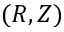Convert formula to latex. <formula><loc_0><loc_0><loc_500><loc_500>( R , Z )</formula> 